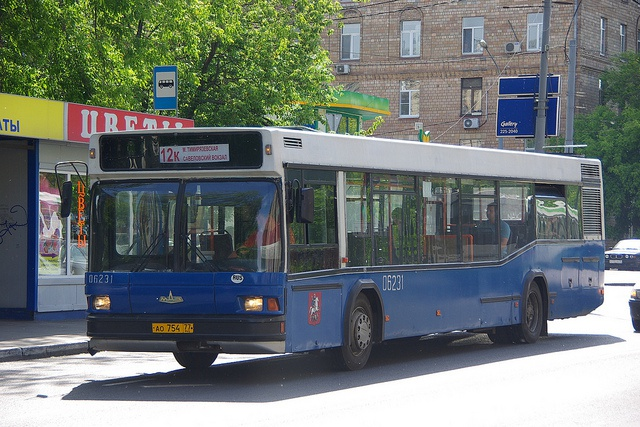Describe the objects in this image and their specific colors. I can see bus in black, gray, navy, and blue tones, people in black, gray, and maroon tones, car in black, white, gray, darkblue, and darkgray tones, people in black, gray, and blue tones, and car in black, gray, and white tones in this image. 